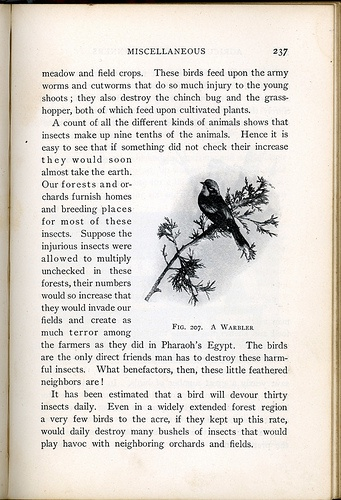Describe the objects in this image and their specific colors. I can see book in white, darkgray, black, and gray tones and bird in black, gray, darkgray, and lightgray tones in this image. 